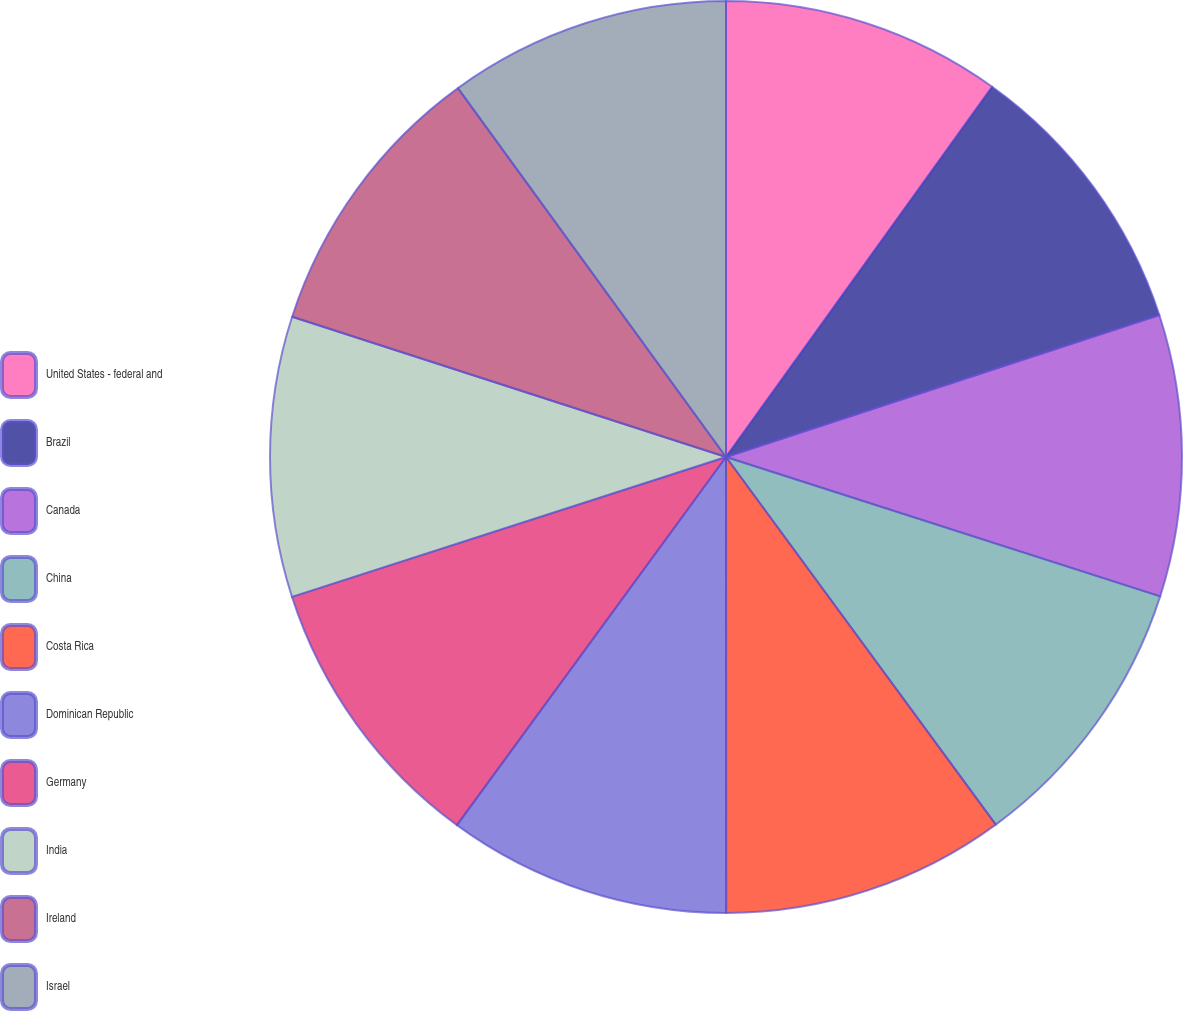Convert chart. <chart><loc_0><loc_0><loc_500><loc_500><pie_chart><fcel>United States - federal and<fcel>Brazil<fcel>Canada<fcel>China<fcel>Costa Rica<fcel>Dominican Republic<fcel>Germany<fcel>India<fcel>Ireland<fcel>Israel<nl><fcel>9.92%<fcel>10.04%<fcel>9.98%<fcel>9.98%<fcel>10.07%<fcel>10.05%<fcel>9.99%<fcel>9.94%<fcel>10.02%<fcel>10.0%<nl></chart> 